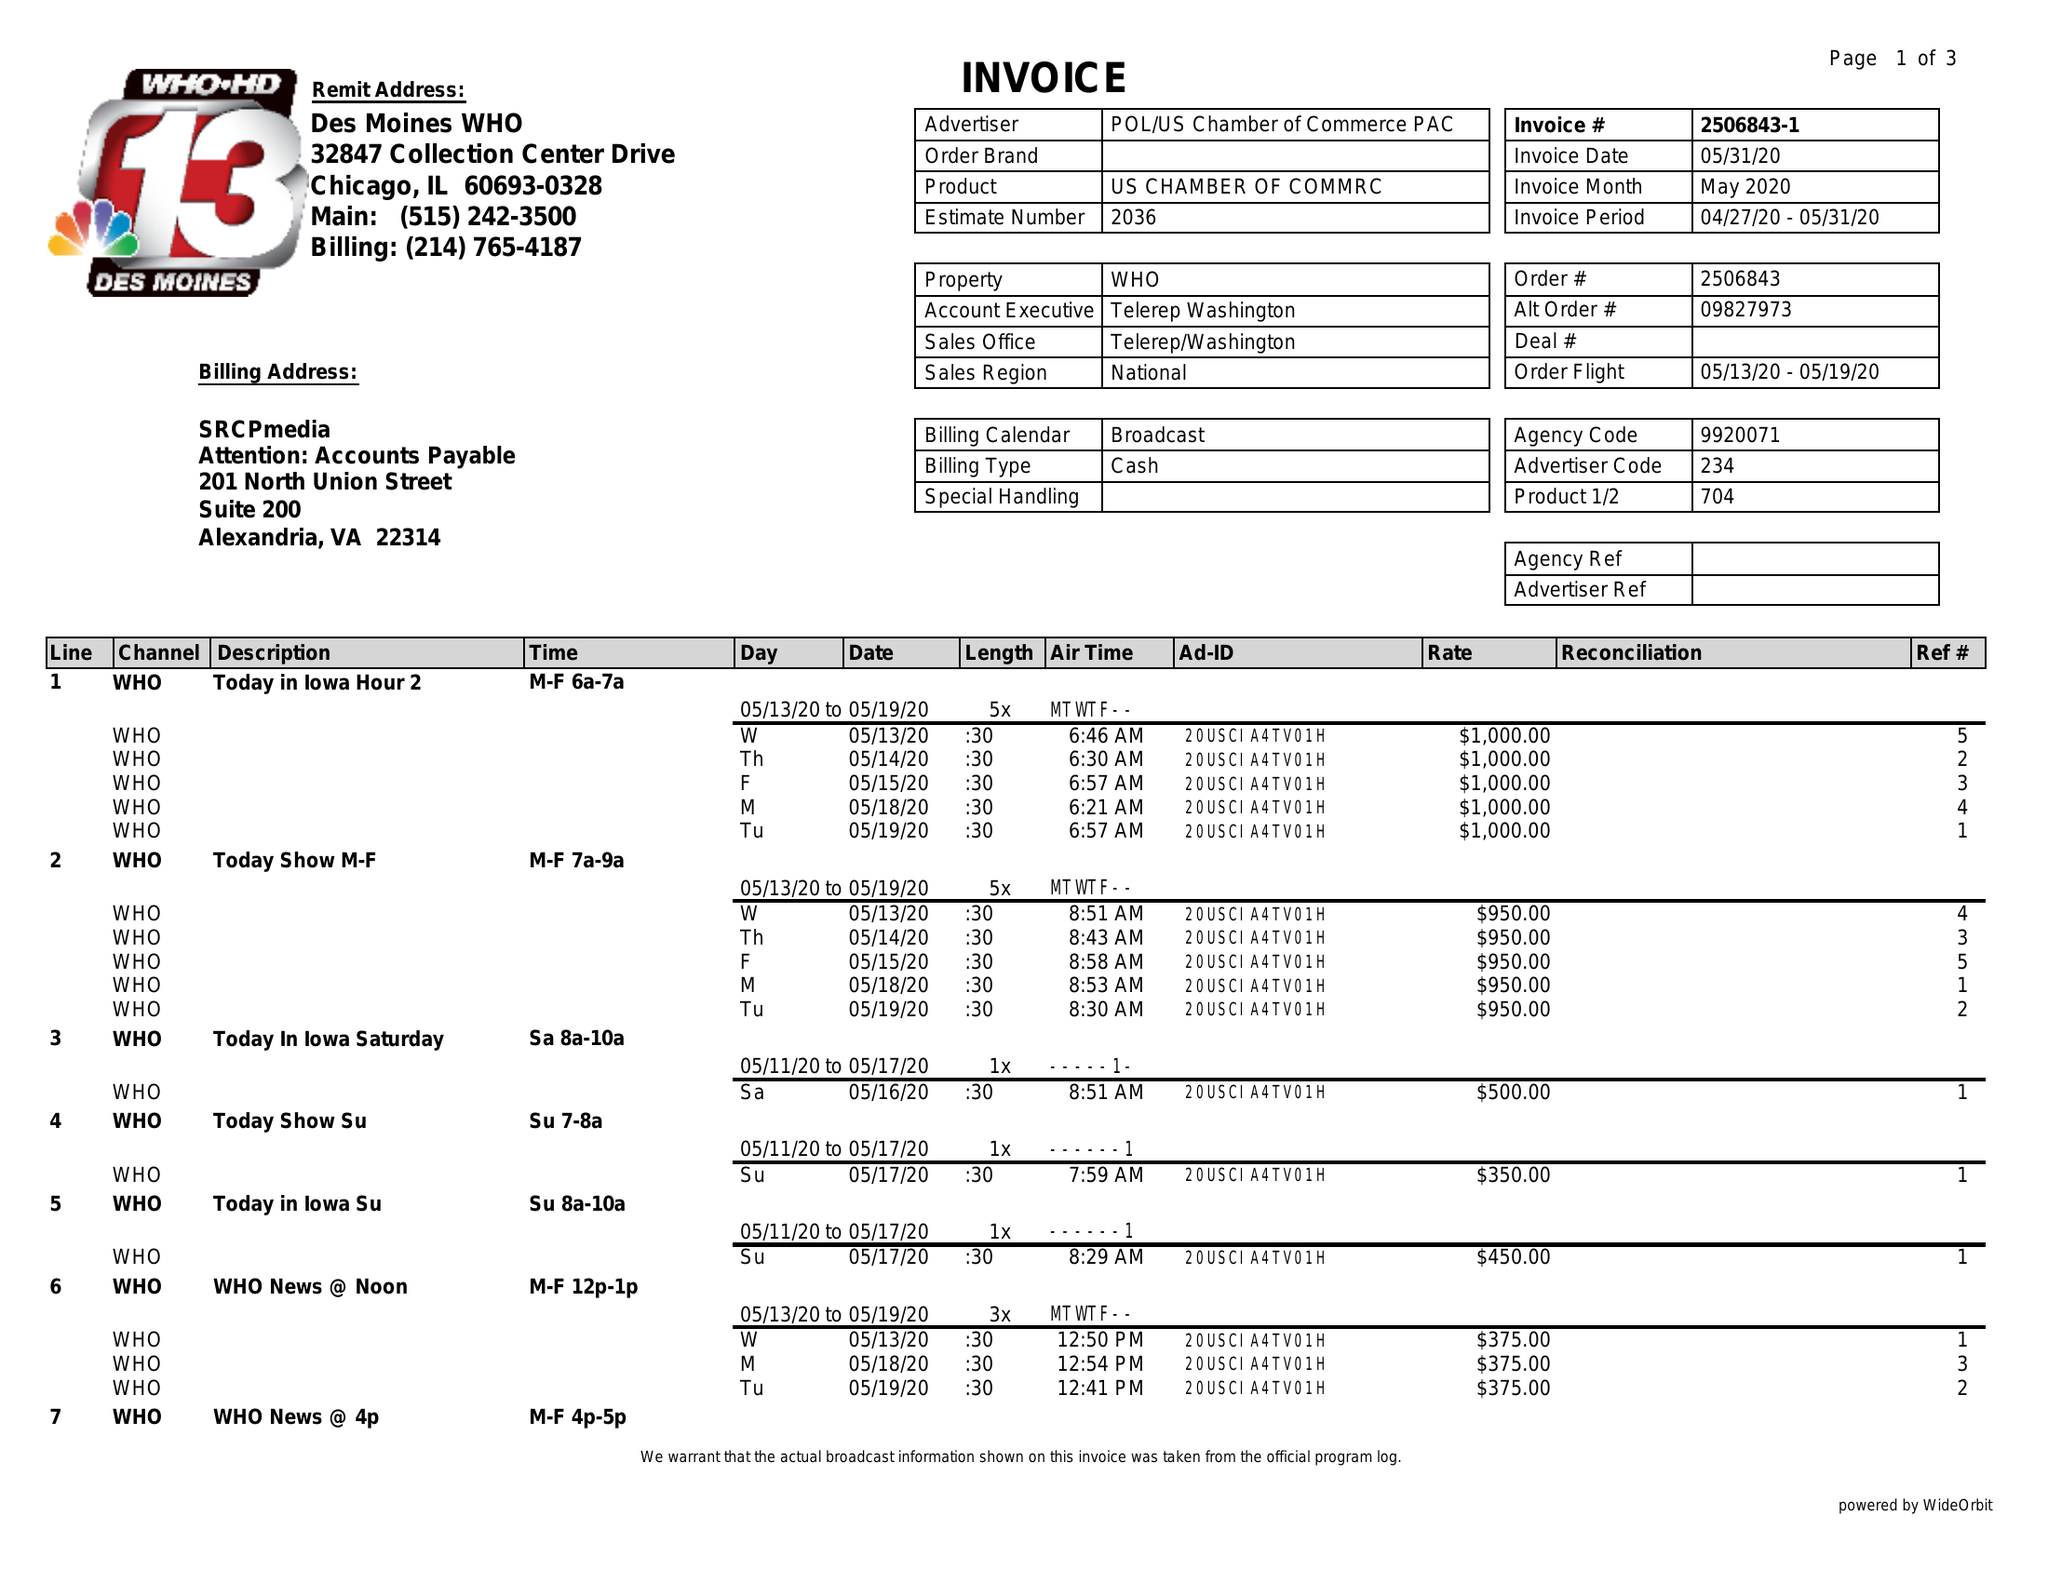What is the value for the gross_amount?
Answer the question using a single word or phrase. 30100.00 